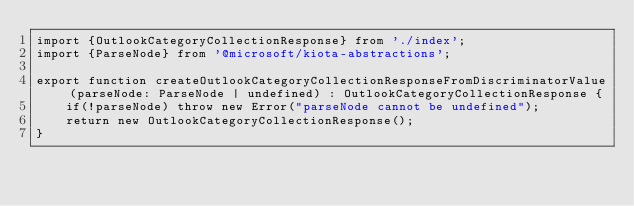Convert code to text. <code><loc_0><loc_0><loc_500><loc_500><_TypeScript_>import {OutlookCategoryCollectionResponse} from './index';
import {ParseNode} from '@microsoft/kiota-abstractions';

export function createOutlookCategoryCollectionResponseFromDiscriminatorValue(parseNode: ParseNode | undefined) : OutlookCategoryCollectionResponse {
    if(!parseNode) throw new Error("parseNode cannot be undefined");
    return new OutlookCategoryCollectionResponse();
}
</code> 